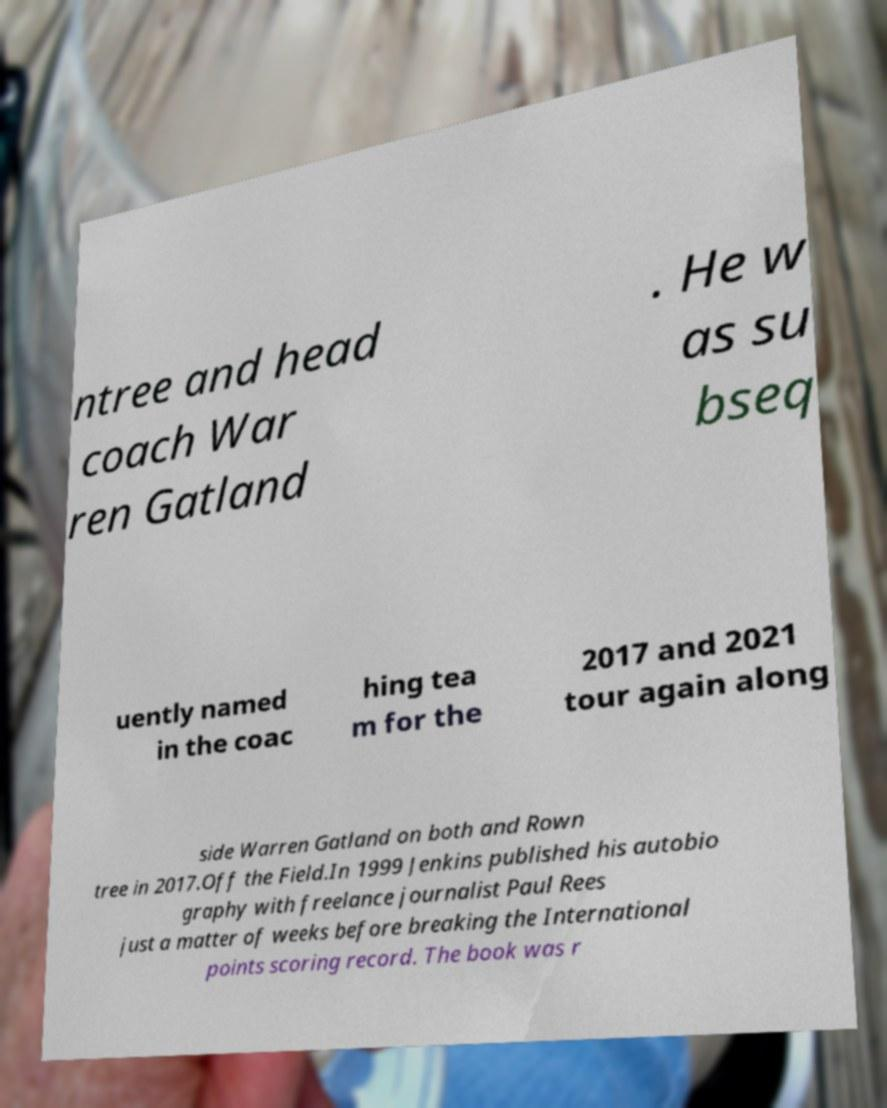What messages or text are displayed in this image? I need them in a readable, typed format. ntree and head coach War ren Gatland . He w as su bseq uently named in the coac hing tea m for the 2017 and 2021 tour again along side Warren Gatland on both and Rown tree in 2017.Off the Field.In 1999 Jenkins published his autobio graphy with freelance journalist Paul Rees just a matter of weeks before breaking the International points scoring record. The book was r 